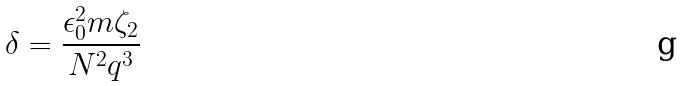Convert formula to latex. <formula><loc_0><loc_0><loc_500><loc_500>\delta = \frac { \epsilon _ { 0 } ^ { 2 } m \zeta _ { 2 } } { N ^ { 2 } q ^ { 3 } }</formula> 